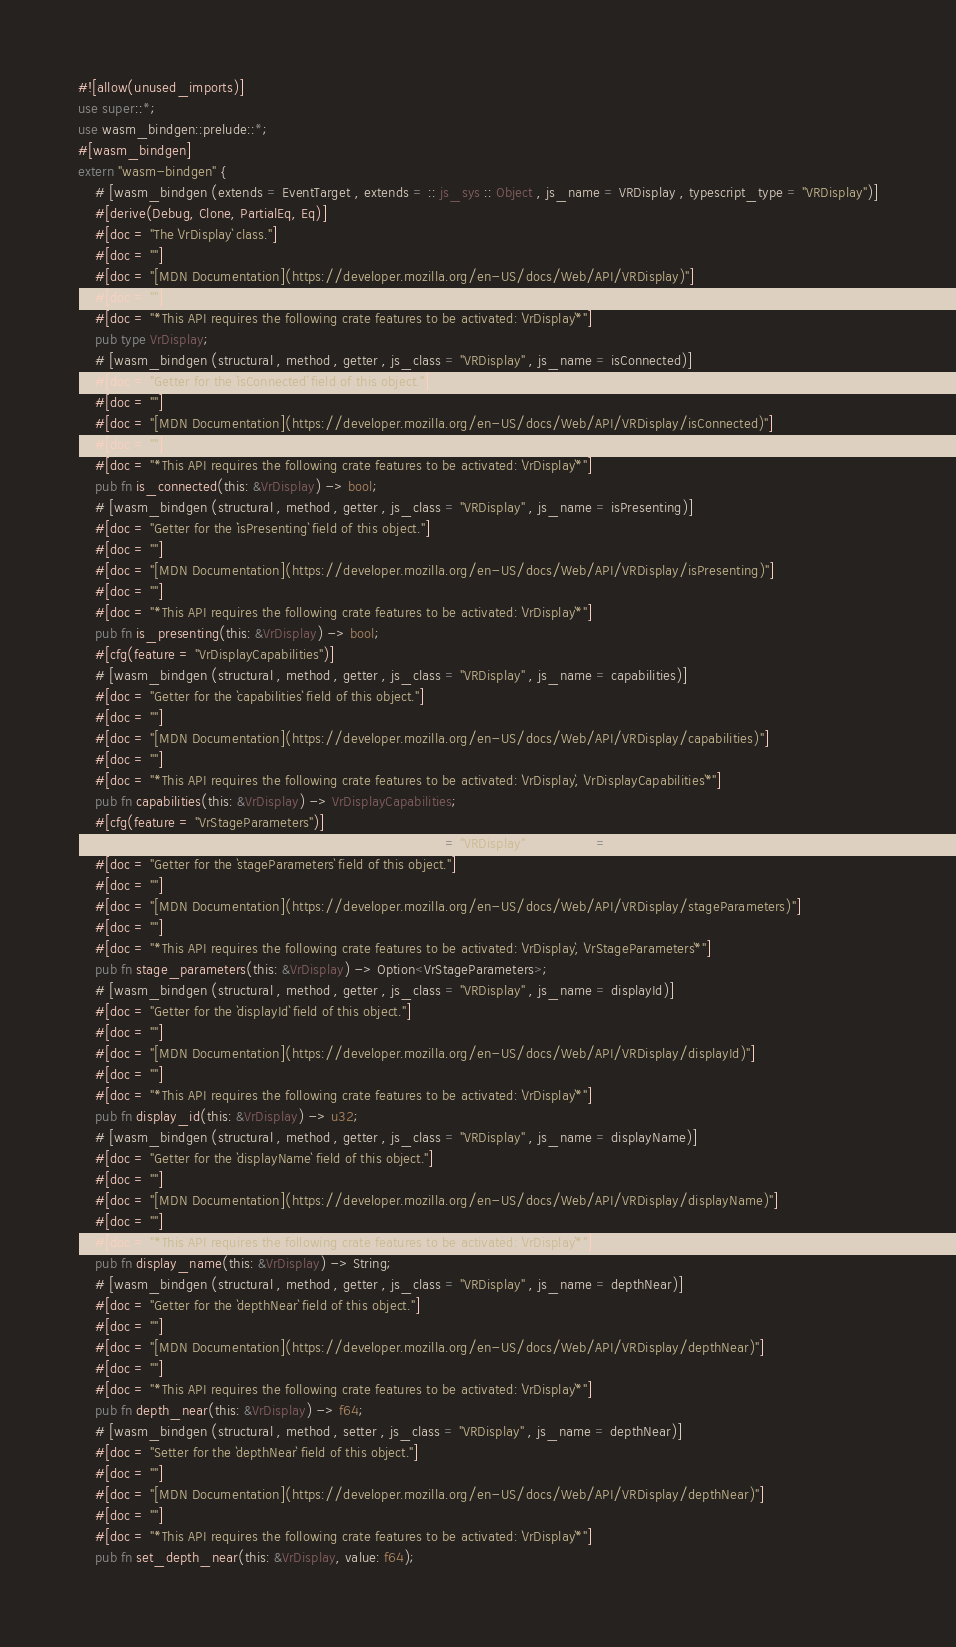<code> <loc_0><loc_0><loc_500><loc_500><_Rust_>#![allow(unused_imports)]
use super::*;
use wasm_bindgen::prelude::*;
#[wasm_bindgen]
extern "wasm-bindgen" {
    # [wasm_bindgen (extends = EventTarget , extends = :: js_sys :: Object , js_name = VRDisplay , typescript_type = "VRDisplay")]
    #[derive(Debug, Clone, PartialEq, Eq)]
    #[doc = "The `VrDisplay` class."]
    #[doc = ""]
    #[doc = "[MDN Documentation](https://developer.mozilla.org/en-US/docs/Web/API/VRDisplay)"]
    #[doc = ""]
    #[doc = "*This API requires the following crate features to be activated: `VrDisplay`*"]
    pub type VrDisplay;
    # [wasm_bindgen (structural , method , getter , js_class = "VRDisplay" , js_name = isConnected)]
    #[doc = "Getter for the `isConnected` field of this object."]
    #[doc = ""]
    #[doc = "[MDN Documentation](https://developer.mozilla.org/en-US/docs/Web/API/VRDisplay/isConnected)"]
    #[doc = ""]
    #[doc = "*This API requires the following crate features to be activated: `VrDisplay`*"]
    pub fn is_connected(this: &VrDisplay) -> bool;
    # [wasm_bindgen (structural , method , getter , js_class = "VRDisplay" , js_name = isPresenting)]
    #[doc = "Getter for the `isPresenting` field of this object."]
    #[doc = ""]
    #[doc = "[MDN Documentation](https://developer.mozilla.org/en-US/docs/Web/API/VRDisplay/isPresenting)"]
    #[doc = ""]
    #[doc = "*This API requires the following crate features to be activated: `VrDisplay`*"]
    pub fn is_presenting(this: &VrDisplay) -> bool;
    #[cfg(feature = "VrDisplayCapabilities")]
    # [wasm_bindgen (structural , method , getter , js_class = "VRDisplay" , js_name = capabilities)]
    #[doc = "Getter for the `capabilities` field of this object."]
    #[doc = ""]
    #[doc = "[MDN Documentation](https://developer.mozilla.org/en-US/docs/Web/API/VRDisplay/capabilities)"]
    #[doc = ""]
    #[doc = "*This API requires the following crate features to be activated: `VrDisplay`, `VrDisplayCapabilities`*"]
    pub fn capabilities(this: &VrDisplay) -> VrDisplayCapabilities;
    #[cfg(feature = "VrStageParameters")]
    # [wasm_bindgen (structural , method , getter , js_class = "VRDisplay" , js_name = stageParameters)]
    #[doc = "Getter for the `stageParameters` field of this object."]
    #[doc = ""]
    #[doc = "[MDN Documentation](https://developer.mozilla.org/en-US/docs/Web/API/VRDisplay/stageParameters)"]
    #[doc = ""]
    #[doc = "*This API requires the following crate features to be activated: `VrDisplay`, `VrStageParameters`*"]
    pub fn stage_parameters(this: &VrDisplay) -> Option<VrStageParameters>;
    # [wasm_bindgen (structural , method , getter , js_class = "VRDisplay" , js_name = displayId)]
    #[doc = "Getter for the `displayId` field of this object."]
    #[doc = ""]
    #[doc = "[MDN Documentation](https://developer.mozilla.org/en-US/docs/Web/API/VRDisplay/displayId)"]
    #[doc = ""]
    #[doc = "*This API requires the following crate features to be activated: `VrDisplay`*"]
    pub fn display_id(this: &VrDisplay) -> u32;
    # [wasm_bindgen (structural , method , getter , js_class = "VRDisplay" , js_name = displayName)]
    #[doc = "Getter for the `displayName` field of this object."]
    #[doc = ""]
    #[doc = "[MDN Documentation](https://developer.mozilla.org/en-US/docs/Web/API/VRDisplay/displayName)"]
    #[doc = ""]
    #[doc = "*This API requires the following crate features to be activated: `VrDisplay`*"]
    pub fn display_name(this: &VrDisplay) -> String;
    # [wasm_bindgen (structural , method , getter , js_class = "VRDisplay" , js_name = depthNear)]
    #[doc = "Getter for the `depthNear` field of this object."]
    #[doc = ""]
    #[doc = "[MDN Documentation](https://developer.mozilla.org/en-US/docs/Web/API/VRDisplay/depthNear)"]
    #[doc = ""]
    #[doc = "*This API requires the following crate features to be activated: `VrDisplay`*"]
    pub fn depth_near(this: &VrDisplay) -> f64;
    # [wasm_bindgen (structural , method , setter , js_class = "VRDisplay" , js_name = depthNear)]
    #[doc = "Setter for the `depthNear` field of this object."]
    #[doc = ""]
    #[doc = "[MDN Documentation](https://developer.mozilla.org/en-US/docs/Web/API/VRDisplay/depthNear)"]
    #[doc = ""]
    #[doc = "*This API requires the following crate features to be activated: `VrDisplay`*"]
    pub fn set_depth_near(this: &VrDisplay, value: f64);</code> 